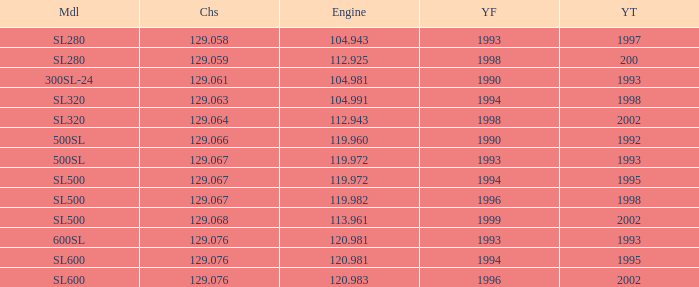How many engines have a Model of sl600, and a Year From of 1994, and a Year To smaller than 1995? 0.0. 